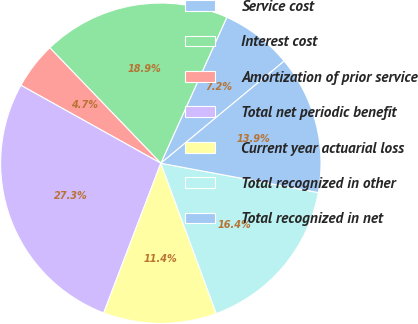Convert chart. <chart><loc_0><loc_0><loc_500><loc_500><pie_chart><fcel>Service cost<fcel>Interest cost<fcel>Amortization of prior service<fcel>Total net periodic benefit<fcel>Current year actuarial loss<fcel>Total recognized in other<fcel>Total recognized in net<nl><fcel>7.23%<fcel>18.95%<fcel>4.72%<fcel>27.29%<fcel>11.43%<fcel>16.45%<fcel>13.94%<nl></chart> 